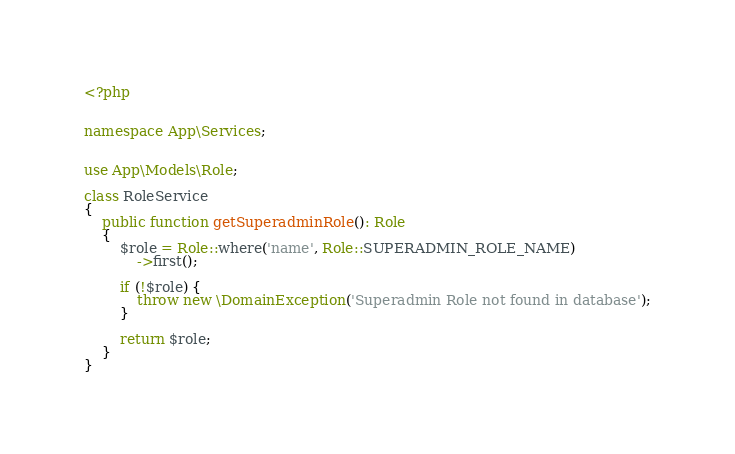Convert code to text. <code><loc_0><loc_0><loc_500><loc_500><_PHP_><?php


namespace App\Services;


use App\Models\Role;

class RoleService
{
    public function getSuperadminRole(): Role
    {
        $role = Role::where('name', Role::SUPERADMIN_ROLE_NAME)
            ->first();

        if (!$role) {
            throw new \DomainException('Superadmin Role not found in database');
        }

        return $role;
    }
}
</code> 